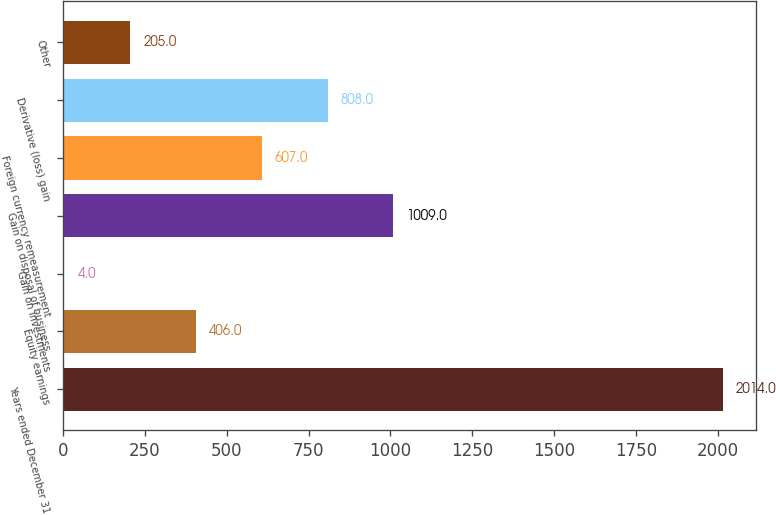Convert chart to OTSL. <chart><loc_0><loc_0><loc_500><loc_500><bar_chart><fcel>Years ended December 31<fcel>Equity earnings<fcel>Gain on investments<fcel>Gain on disposal of business<fcel>Foreign currency remeasurement<fcel>Derivative (loss) gain<fcel>Other<nl><fcel>2014<fcel>406<fcel>4<fcel>1009<fcel>607<fcel>808<fcel>205<nl></chart> 